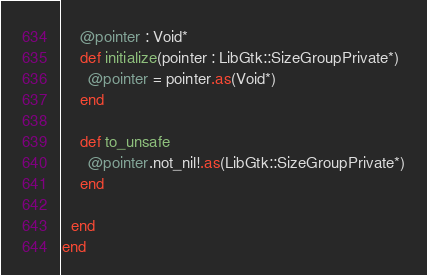Convert code to text. <code><loc_0><loc_0><loc_500><loc_500><_Crystal_>    @pointer : Void*
    def initialize(pointer : LibGtk::SizeGroupPrivate*)
      @pointer = pointer.as(Void*)
    end

    def to_unsafe
      @pointer.not_nil!.as(LibGtk::SizeGroupPrivate*)
    end

  end
end

</code> 